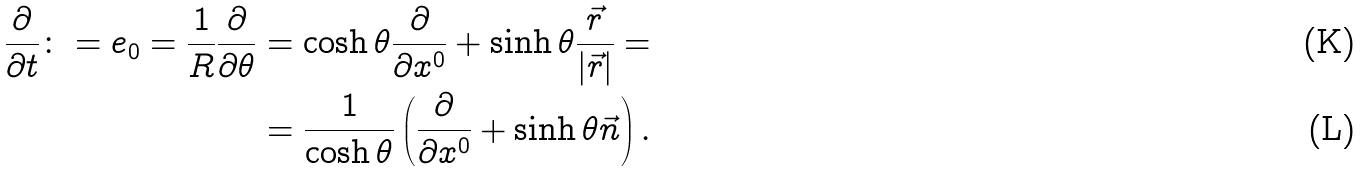Convert formula to latex. <formula><loc_0><loc_0><loc_500><loc_500>\frac { \partial } { \partial t } \colon = { e } _ { 0 } = \frac { 1 } { R } \frac { \partial } { \partial \theta } & = \cosh { \theta } \frac { \partial } { \partial { x } ^ { 0 } } + \sinh { \theta } \frac { \vec { r } } { | \vec { r } | } = \\ & = \frac { 1 } { \cosh { \theta } } \left ( \frac { \partial } { \partial { x } ^ { 0 } } + \sinh { \theta } \vec { n } \right ) .</formula> 